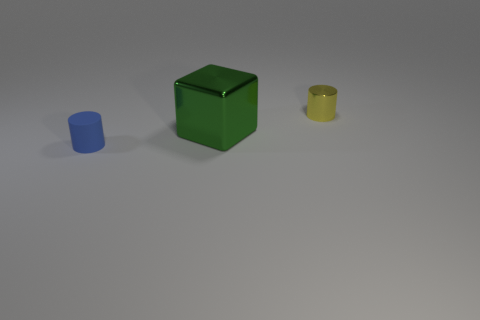Are there the same number of blue cylinders that are right of the green object and tiny metallic things behind the yellow metallic object?
Your answer should be very brief. Yes. What number of other things are the same material as the big green cube?
Offer a terse response. 1. Are there the same number of shiny cylinders on the left side of the yellow shiny object and big cyan metal objects?
Offer a terse response. Yes. Does the yellow thing have the same size as the cylinder on the left side of the small yellow metallic cylinder?
Offer a terse response. Yes. The tiny thing that is in front of the yellow shiny object has what shape?
Offer a very short reply. Cylinder. Is there anything else that is the same shape as the large green metal thing?
Your answer should be compact. No. Are there any big metallic things?
Your answer should be compact. Yes. There is a shiny thing that is in front of the yellow shiny object; does it have the same size as the thing behind the large green block?
Make the answer very short. No. There is a thing that is behind the small rubber cylinder and in front of the small yellow object; what material is it made of?
Offer a very short reply. Metal. What number of metal things are on the right side of the big metallic object?
Your answer should be compact. 1. 